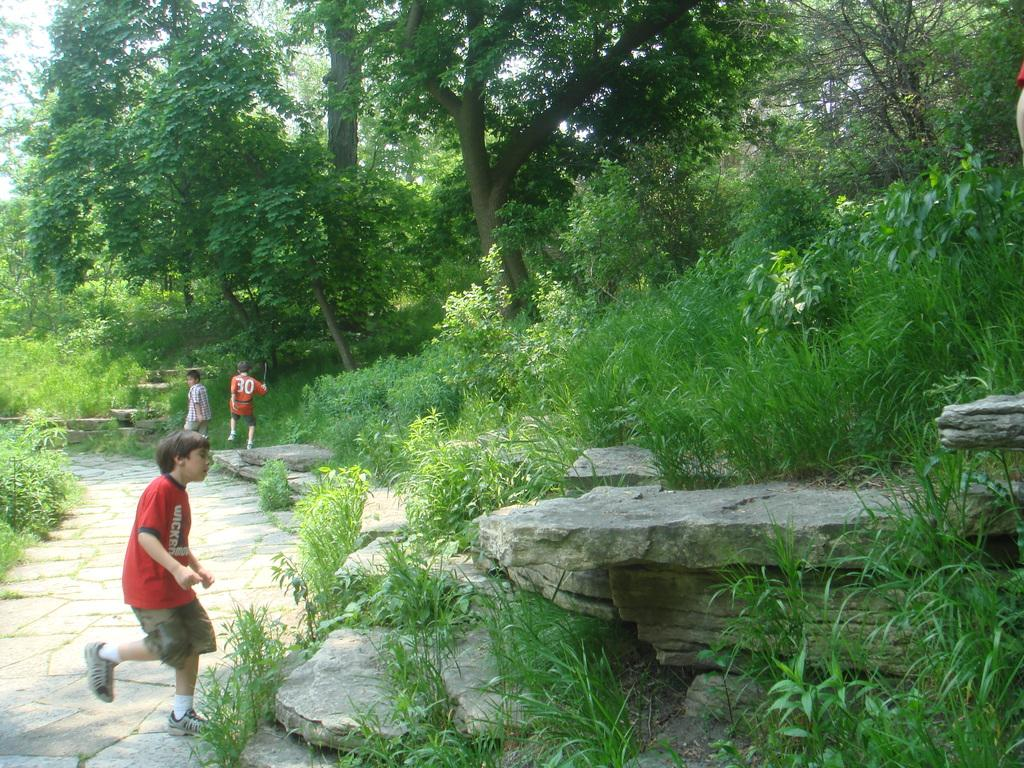How many people are in the image? There are three persons in the image. Can you describe the clothing of one of the persons? One person is wearing a red and brown color dress. What can be seen in the background of the image? There are trees and the sky visible in the background of the image. What is the color of the trees in the image? The trees are green in color. What is the color of the sky in the image? The sky is white in color. Can you tell me what type of doctor is standing next to the frog in the image? There is no doctor or frog present in the image. 